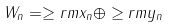<formula> <loc_0><loc_0><loc_500><loc_500>W _ { n } = \geq r m x _ { n } \oplus \geq r m y _ { n }</formula> 